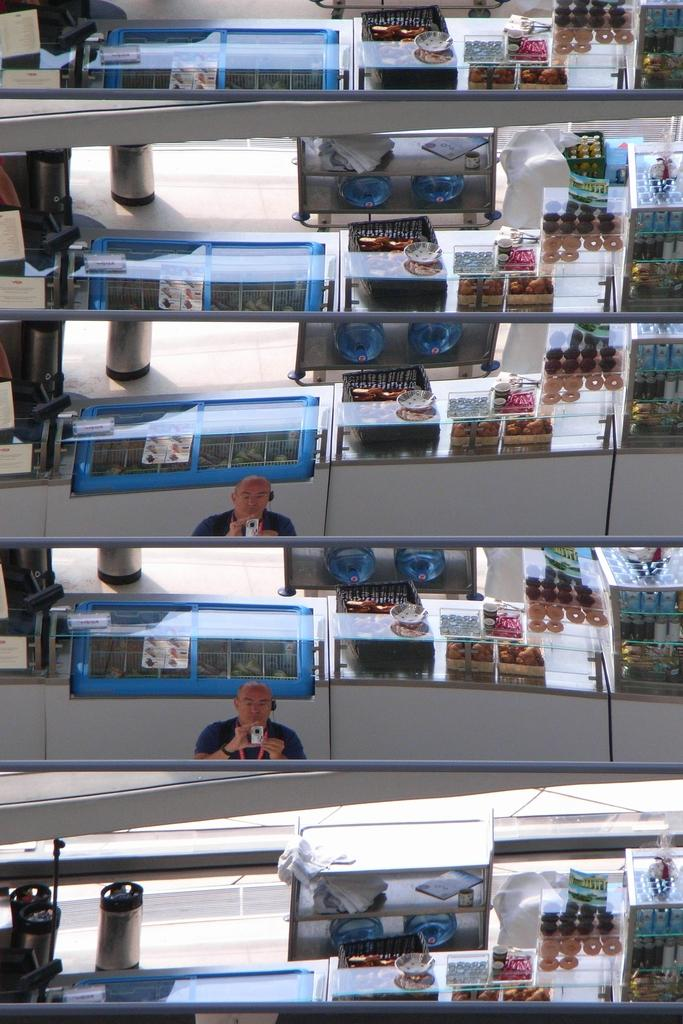What type of image is being described? The image is a collage. What can be seen in the collage related to storage? There are water cans in a rack. What can be seen in the collage related to food? There are food items in display counters. What can be seen in the collage related to waste management? There are dustbins in the image. What can be seen in the collage related to photography? There is a person holding a camera in the image. What else can be seen in the collage? There are other objects present in the image. What type of sea creature can be seen in the image? There is no sea creature present in the image; it is a collage featuring water cans, food items, dustbins, and a person holding a camera. What type of sock is being worn by the person holding the camera? There is no person's sock visible in the image, as the focus is on the person holding the camera and not their clothing. 